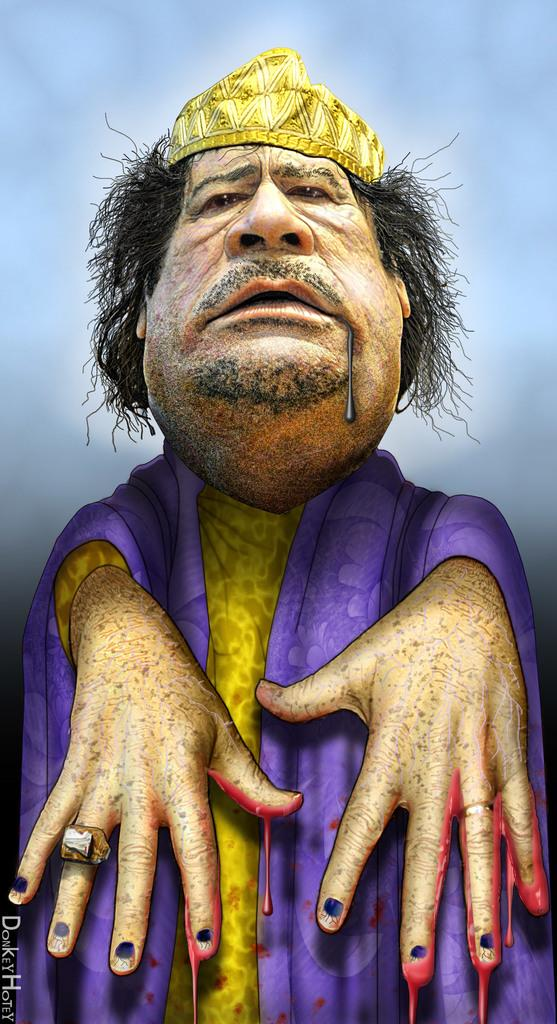What type of image is shown in the picture? The image is an edited image. What is the main subject of the edited image? The edited image depicts a person. What type of toy can be seen in the hands of the person in the image? There is no toy visible in the image; it only depicts a person. How many family members are present in the image? There is no reference to a family or any family members in the image, as it only depicts a person. 